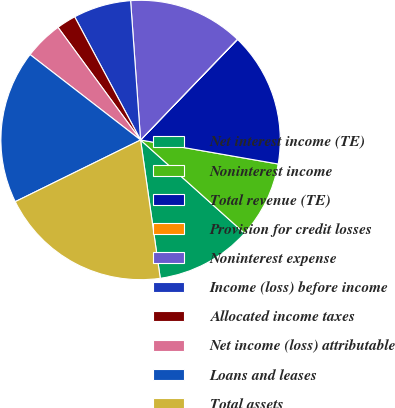Convert chart to OTSL. <chart><loc_0><loc_0><loc_500><loc_500><pie_chart><fcel>Net interest income (TE)<fcel>Noninterest income<fcel>Total revenue (TE)<fcel>Provision for credit losses<fcel>Noninterest expense<fcel>Income (loss) before income<fcel>Allocated income taxes<fcel>Net income (loss) attributable<fcel>Loans and leases<fcel>Total assets<nl><fcel>11.11%<fcel>8.89%<fcel>15.54%<fcel>0.03%<fcel>13.32%<fcel>6.68%<fcel>2.25%<fcel>4.46%<fcel>17.75%<fcel>19.97%<nl></chart> 